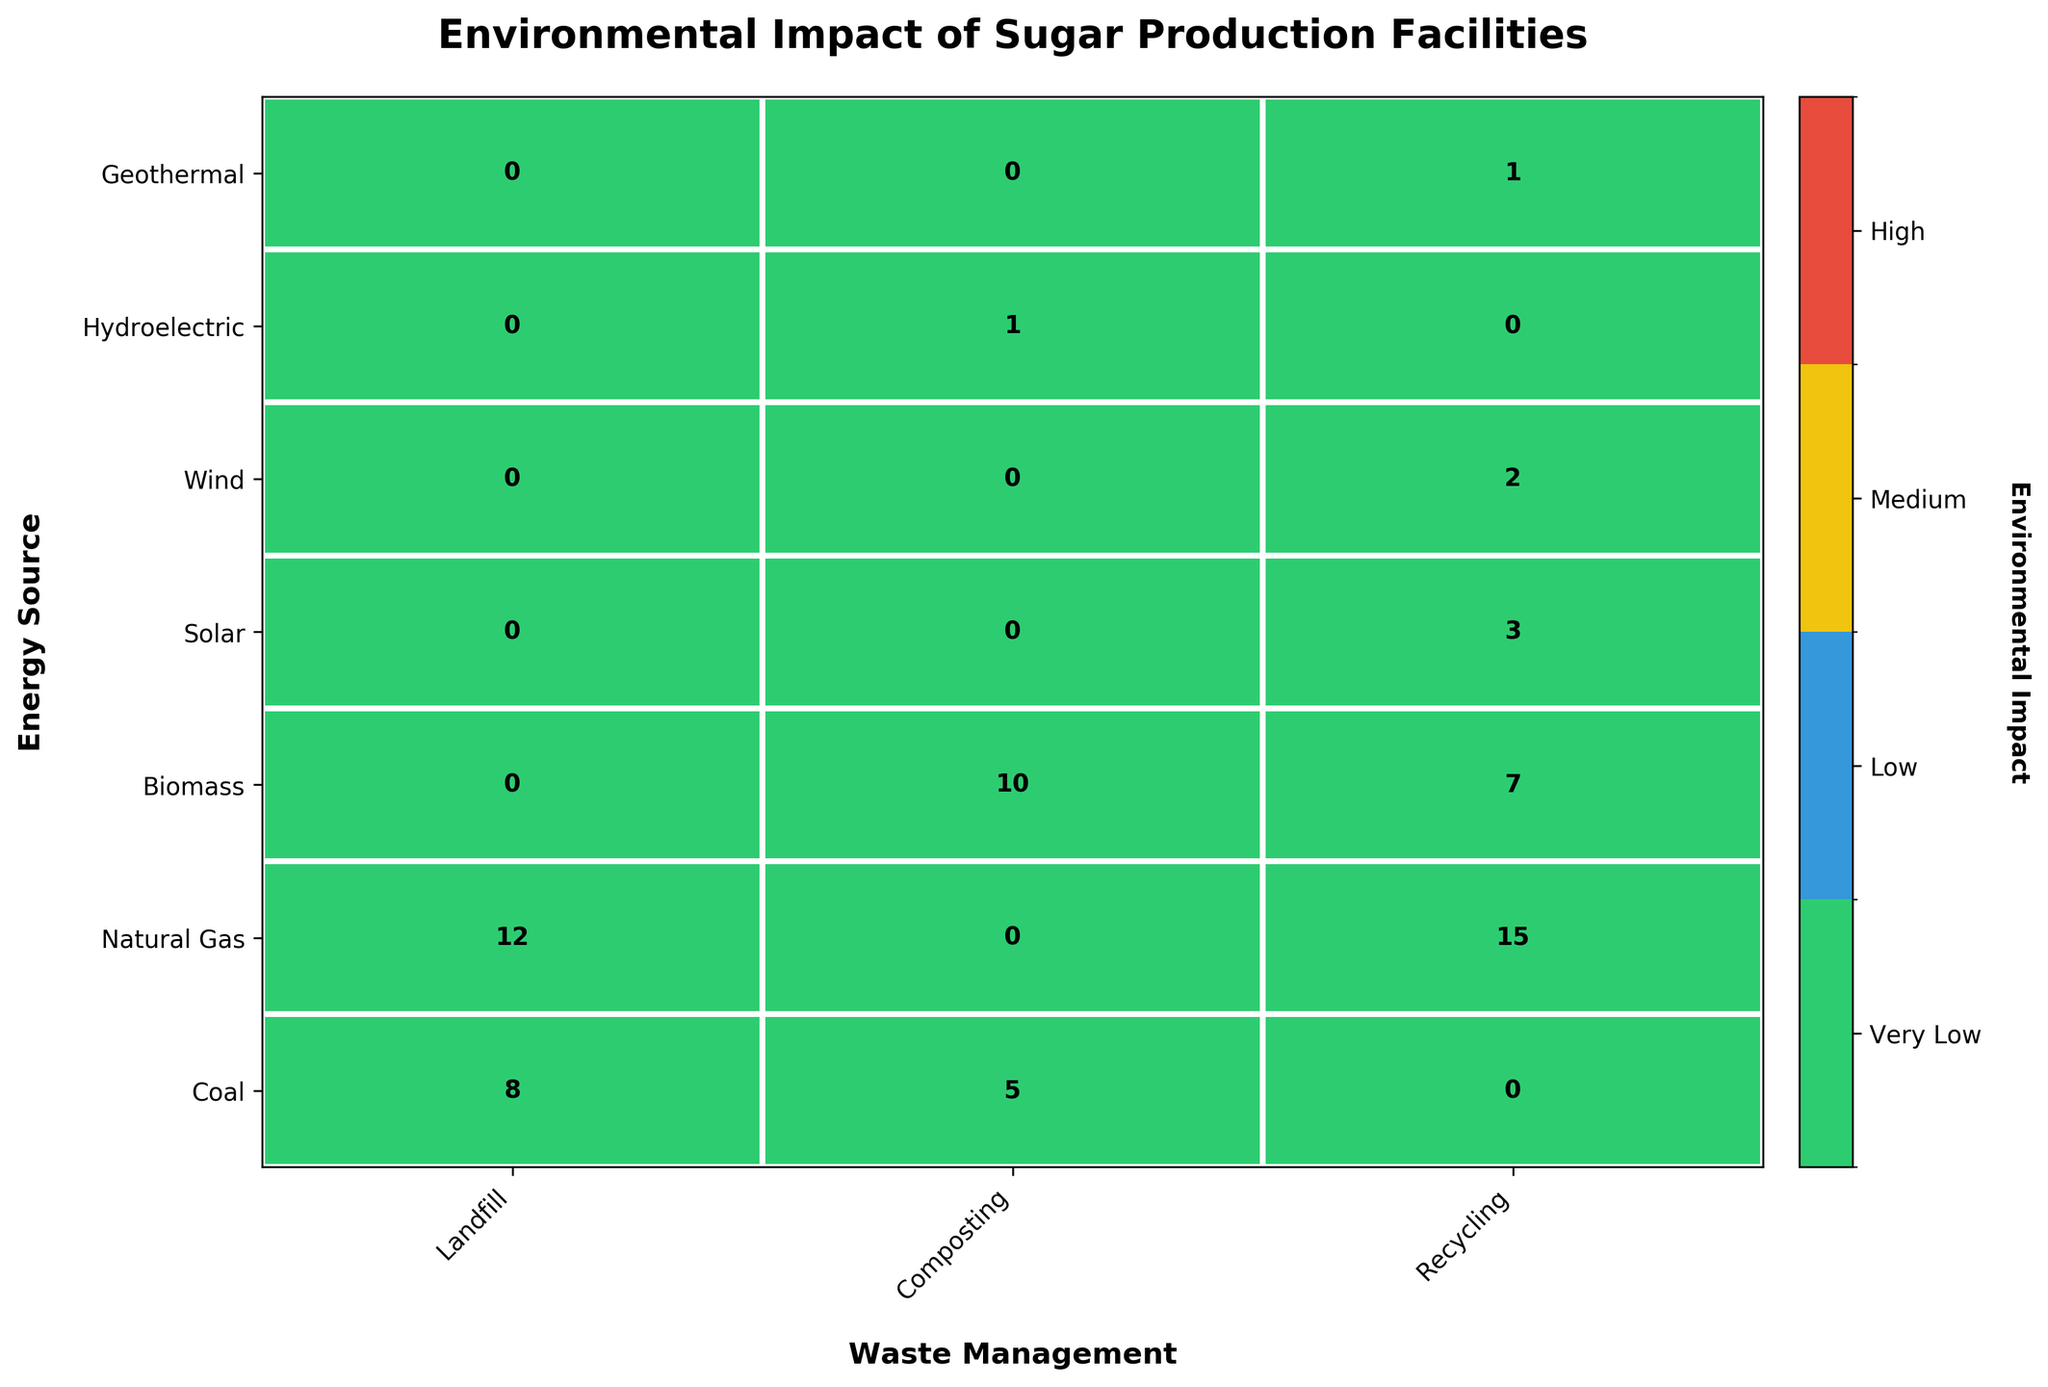What is the title of the figure? The title of the figure is typically displayed at the top of the chart in bold and larger font size, serving as a descriptive headline that summarizes the content of the plot.
Answer: Environmental Impact of Sugar Production Facilities How many factories use Biomass as their energy source? To find the total number of factories using Biomass, sum up the values in the row labeled "Biomass" across all waste management categories in the plot. The values are 10 (Composting) + 7 (Recycling).
Answer: 17 Which energy source and waste management combination has the highest factory count? Look for the cell with the largest number in the mosaic plot. The highest value corresponds to Natural Gas with Landfill waste management at 12 factories.
Answer: Natural Gas, Landfill Compare the environmental impact of facilities using Coal vs. Biomass. Which has a greater impact? Focus on the shading or color indicating the environmental impact levels. Coal has a "High" and "Medium" impact (i.e., higher impact levels), while Biomass has "Low" and "Very Low" impacts. Coal has a greater impact.
Answer: Coal How many facilities are managed with "Recycling" waste management? Sum up all the values in the "Recycling" column regardless of the energy sources. The values are 15 (Natural Gas) + 7 (Biomass) + 3 (Solar) + 2 (Wind) + 1 (Geothermal).
Answer: 28 What is the combined count of factories that use Solar and Wind energy? Sum up the factory counts for Solar and Wind in the plot. For Solar: 3 (Recycling), and for Wind: 2 (Recycling).
Answer: 5 Which waste management practice shows the lowest environmental impact among all energy sources? Identify the waste management practice associated with the "Very Low" impact category, indicated by the least intense color. The majority of "Very Low" impact is seen in the "Recycling" category.
Answer: Recycling What is the total number of factories represented in the mosaic plot? Sum all the factory counts across the entire plot. The values are: 8 + 5 + 12 + 15 + 10 + 7 + 3 + 2 + 1 + 1.
Answer: 64 Which energy sources are associated with “Very Low” environmental impact? Identify rows where the color corresponding to 'Very Low' appears. The energy sources are Biomass, Solar, Wind, and Geothermal.
Answer: Biomass, Solar, Wind, Geothermal Are there any energy sources that do not use "Recycling" for waste management? Check rows for energy sources that have zero count cells in the "Recycling" column. The energy sources without any "Recycling": Coal and Hydroelectric.
Answer: Coal, Hydroelectric 